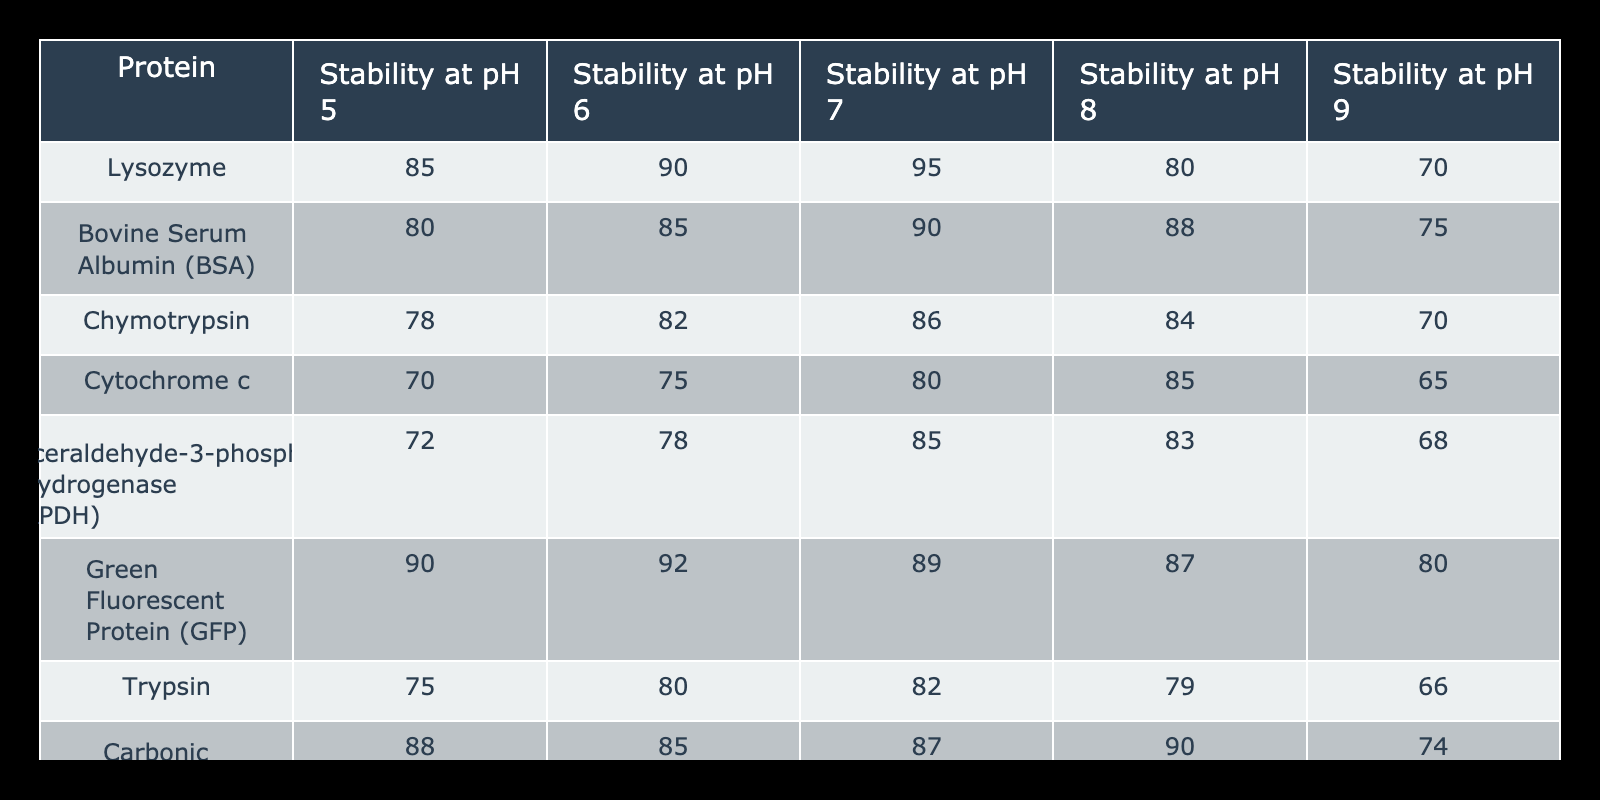What is the stability of Lysozyme at pH 7? The table shows the stability value for Lysozyme under different pH levels. At pH 7, the stability is listed directly under the corresponding column for Lysozyme.
Answer: 95 Which protein has the highest stability at pH 6? To find the highest stability at pH 6, I can compare the stability values of all proteins in the pH 6 column, which shows that Green Fluorescent Protein has the highest value at 92.
Answer: Green Fluorescent Protein Is the stability of Trypsin at pH 8 greater than that at pH 9? I compare the stability values for Trypsin at both pH levels. The table indicates the stability at pH 8 is 79 and at pH 9 is 66, confirming that 79 is greater than 66.
Answer: Yes What is the average stability of the proteins at pH 5? To calculate the average at pH 5, I sum the stability values: (85 + 80 + 78 + 70 + 72 + 90 + 75 + 88) = 738. There are 8 proteins, so the average is 738/8 = 92.25.
Answer: 92.25 Is the stability of Carbonic Anhydrase consistent across all pH levels? To determine if Carbonic Anhydrase's stability is consistent, I assess the stability values across all pH levels: 88 (pH 5), 85 (pH 6), 87 (pH 7), 90 (pH 8), and 74 (pH 9). The values vary, indicating inconsistency.
Answer: No What are the stability values for Bovine Serum Albumin at pH 7 and pH 8? I look at the stability values under the Bovine Serum Albumin row specifically for pH 7 and pH 8. At pH 7, the stability is 90, while at pH 8, it is 88.
Answer: 90 and 88 Which two proteins show the greatest difference in stability at pH 9? I examine the stability values at pH 9, which are: Lysozyme 70, BSA 75, Chymotrypsin 70, Cytochrome c 65, GAPDH 68, GFP 80, Trypsin 66, and Carbonic Anhydrase 74. The maximum difference is between BSA (75) and Cytochrome c (65), yielding a difference of 10.
Answer: BSA and Cytochrome c At which pH does Chymotrypsin exhibit the lowest stability? Looking at the Chymotrypsin row across all pH columns, the lowest stability value is at pH 9, where the stability is 70.
Answer: pH 9 